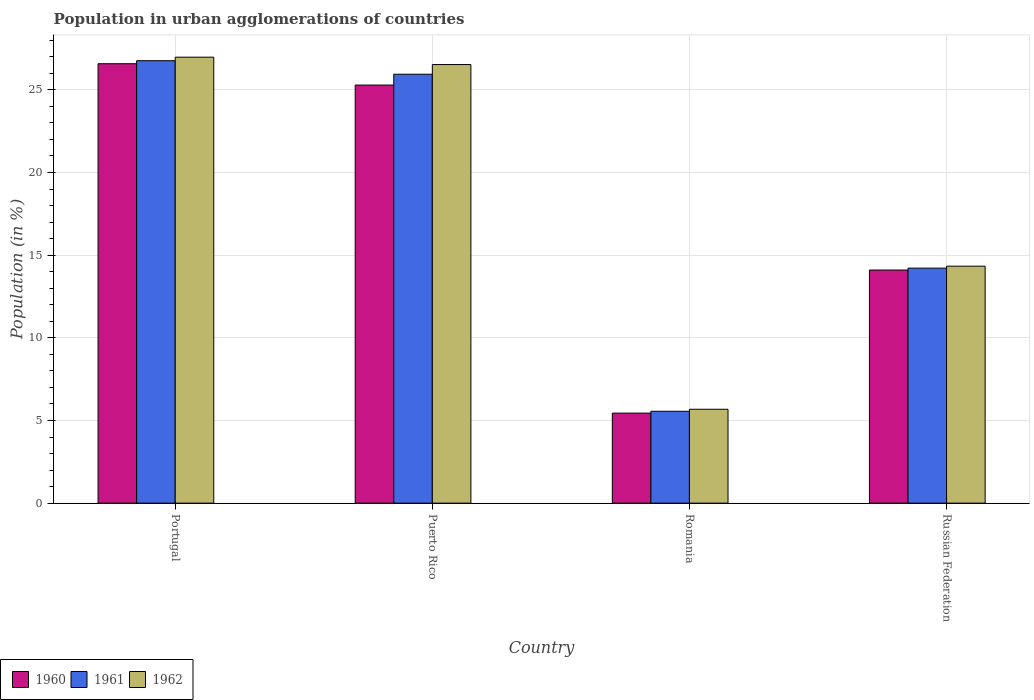How many different coloured bars are there?
Offer a terse response. 3. How many groups of bars are there?
Your response must be concise. 4. Are the number of bars per tick equal to the number of legend labels?
Keep it short and to the point. Yes. How many bars are there on the 3rd tick from the right?
Offer a terse response. 3. What is the label of the 4th group of bars from the left?
Make the answer very short. Russian Federation. What is the percentage of population in urban agglomerations in 1961 in Russian Federation?
Your answer should be very brief. 14.21. Across all countries, what is the maximum percentage of population in urban agglomerations in 1960?
Provide a succinct answer. 26.58. Across all countries, what is the minimum percentage of population in urban agglomerations in 1962?
Your response must be concise. 5.68. In which country was the percentage of population in urban agglomerations in 1962 minimum?
Make the answer very short. Romania. What is the total percentage of population in urban agglomerations in 1961 in the graph?
Ensure brevity in your answer.  72.47. What is the difference between the percentage of population in urban agglomerations in 1962 in Portugal and that in Puerto Rico?
Keep it short and to the point. 0.45. What is the difference between the percentage of population in urban agglomerations in 1962 in Portugal and the percentage of population in urban agglomerations in 1961 in Puerto Rico?
Make the answer very short. 1.03. What is the average percentage of population in urban agglomerations in 1962 per country?
Keep it short and to the point. 18.38. What is the difference between the percentage of population in urban agglomerations of/in 1961 and percentage of population in urban agglomerations of/in 1960 in Portugal?
Offer a very short reply. 0.18. What is the ratio of the percentage of population in urban agglomerations in 1962 in Portugal to that in Romania?
Make the answer very short. 4.75. What is the difference between the highest and the second highest percentage of population in urban agglomerations in 1961?
Keep it short and to the point. -0.82. What is the difference between the highest and the lowest percentage of population in urban agglomerations in 1960?
Offer a very short reply. 21.13. In how many countries, is the percentage of population in urban agglomerations in 1961 greater than the average percentage of population in urban agglomerations in 1961 taken over all countries?
Provide a short and direct response. 2. Is the sum of the percentage of population in urban agglomerations in 1962 in Puerto Rico and Romania greater than the maximum percentage of population in urban agglomerations in 1960 across all countries?
Ensure brevity in your answer.  Yes. What does the 1st bar from the right in Russian Federation represents?
Offer a very short reply. 1962. Is it the case that in every country, the sum of the percentage of population in urban agglomerations in 1960 and percentage of population in urban agglomerations in 1961 is greater than the percentage of population in urban agglomerations in 1962?
Your answer should be very brief. Yes. How many bars are there?
Your answer should be compact. 12. Are all the bars in the graph horizontal?
Your answer should be compact. No. What is the difference between two consecutive major ticks on the Y-axis?
Your answer should be compact. 5. Are the values on the major ticks of Y-axis written in scientific E-notation?
Make the answer very short. No. Does the graph contain any zero values?
Keep it short and to the point. No. Does the graph contain grids?
Your answer should be compact. Yes. What is the title of the graph?
Keep it short and to the point. Population in urban agglomerations of countries. What is the label or title of the X-axis?
Offer a terse response. Country. What is the Population (in %) in 1960 in Portugal?
Provide a succinct answer. 26.58. What is the Population (in %) in 1961 in Portugal?
Your response must be concise. 26.76. What is the Population (in %) in 1962 in Portugal?
Make the answer very short. 26.97. What is the Population (in %) of 1960 in Puerto Rico?
Keep it short and to the point. 25.29. What is the Population (in %) of 1961 in Puerto Rico?
Provide a short and direct response. 25.94. What is the Population (in %) of 1962 in Puerto Rico?
Offer a terse response. 26.53. What is the Population (in %) of 1960 in Romania?
Your answer should be compact. 5.45. What is the Population (in %) of 1961 in Romania?
Make the answer very short. 5.56. What is the Population (in %) in 1962 in Romania?
Make the answer very short. 5.68. What is the Population (in %) in 1960 in Russian Federation?
Offer a very short reply. 14.1. What is the Population (in %) in 1961 in Russian Federation?
Your response must be concise. 14.21. What is the Population (in %) of 1962 in Russian Federation?
Give a very brief answer. 14.33. Across all countries, what is the maximum Population (in %) in 1960?
Your answer should be compact. 26.58. Across all countries, what is the maximum Population (in %) of 1961?
Ensure brevity in your answer.  26.76. Across all countries, what is the maximum Population (in %) of 1962?
Offer a terse response. 26.97. Across all countries, what is the minimum Population (in %) in 1960?
Provide a short and direct response. 5.45. Across all countries, what is the minimum Population (in %) of 1961?
Keep it short and to the point. 5.56. Across all countries, what is the minimum Population (in %) of 1962?
Give a very brief answer. 5.68. What is the total Population (in %) in 1960 in the graph?
Your answer should be very brief. 71.41. What is the total Population (in %) of 1961 in the graph?
Provide a short and direct response. 72.47. What is the total Population (in %) of 1962 in the graph?
Provide a short and direct response. 73.51. What is the difference between the Population (in %) of 1960 in Portugal and that in Puerto Rico?
Ensure brevity in your answer.  1.29. What is the difference between the Population (in %) of 1961 in Portugal and that in Puerto Rico?
Keep it short and to the point. 0.82. What is the difference between the Population (in %) of 1962 in Portugal and that in Puerto Rico?
Ensure brevity in your answer.  0.45. What is the difference between the Population (in %) in 1960 in Portugal and that in Romania?
Provide a short and direct response. 21.13. What is the difference between the Population (in %) of 1961 in Portugal and that in Romania?
Your answer should be compact. 21.2. What is the difference between the Population (in %) of 1962 in Portugal and that in Romania?
Offer a terse response. 21.3. What is the difference between the Population (in %) in 1960 in Portugal and that in Russian Federation?
Offer a very short reply. 12.48. What is the difference between the Population (in %) of 1961 in Portugal and that in Russian Federation?
Offer a very short reply. 12.54. What is the difference between the Population (in %) in 1962 in Portugal and that in Russian Federation?
Offer a terse response. 12.64. What is the difference between the Population (in %) of 1960 in Puerto Rico and that in Romania?
Provide a succinct answer. 19.84. What is the difference between the Population (in %) in 1961 in Puerto Rico and that in Romania?
Give a very brief answer. 20.39. What is the difference between the Population (in %) of 1962 in Puerto Rico and that in Romania?
Your answer should be compact. 20.85. What is the difference between the Population (in %) of 1960 in Puerto Rico and that in Russian Federation?
Your response must be concise. 11.19. What is the difference between the Population (in %) in 1961 in Puerto Rico and that in Russian Federation?
Ensure brevity in your answer.  11.73. What is the difference between the Population (in %) in 1962 in Puerto Rico and that in Russian Federation?
Ensure brevity in your answer.  12.19. What is the difference between the Population (in %) in 1960 in Romania and that in Russian Federation?
Your response must be concise. -8.65. What is the difference between the Population (in %) in 1961 in Romania and that in Russian Federation?
Provide a short and direct response. -8.66. What is the difference between the Population (in %) in 1962 in Romania and that in Russian Federation?
Provide a short and direct response. -8.65. What is the difference between the Population (in %) in 1960 in Portugal and the Population (in %) in 1961 in Puerto Rico?
Your answer should be very brief. 0.64. What is the difference between the Population (in %) of 1960 in Portugal and the Population (in %) of 1962 in Puerto Rico?
Give a very brief answer. 0.05. What is the difference between the Population (in %) in 1961 in Portugal and the Population (in %) in 1962 in Puerto Rico?
Your answer should be compact. 0.23. What is the difference between the Population (in %) in 1960 in Portugal and the Population (in %) in 1961 in Romania?
Your response must be concise. 21.02. What is the difference between the Population (in %) in 1960 in Portugal and the Population (in %) in 1962 in Romania?
Make the answer very short. 20.9. What is the difference between the Population (in %) in 1961 in Portugal and the Population (in %) in 1962 in Romania?
Offer a very short reply. 21.08. What is the difference between the Population (in %) of 1960 in Portugal and the Population (in %) of 1961 in Russian Federation?
Give a very brief answer. 12.36. What is the difference between the Population (in %) of 1960 in Portugal and the Population (in %) of 1962 in Russian Federation?
Your answer should be very brief. 12.24. What is the difference between the Population (in %) in 1961 in Portugal and the Population (in %) in 1962 in Russian Federation?
Keep it short and to the point. 12.43. What is the difference between the Population (in %) of 1960 in Puerto Rico and the Population (in %) of 1961 in Romania?
Provide a short and direct response. 19.73. What is the difference between the Population (in %) in 1960 in Puerto Rico and the Population (in %) in 1962 in Romania?
Provide a short and direct response. 19.61. What is the difference between the Population (in %) in 1961 in Puerto Rico and the Population (in %) in 1962 in Romania?
Give a very brief answer. 20.26. What is the difference between the Population (in %) of 1960 in Puerto Rico and the Population (in %) of 1961 in Russian Federation?
Your response must be concise. 11.07. What is the difference between the Population (in %) of 1960 in Puerto Rico and the Population (in %) of 1962 in Russian Federation?
Keep it short and to the point. 10.95. What is the difference between the Population (in %) in 1961 in Puerto Rico and the Population (in %) in 1962 in Russian Federation?
Provide a succinct answer. 11.61. What is the difference between the Population (in %) of 1960 in Romania and the Population (in %) of 1961 in Russian Federation?
Ensure brevity in your answer.  -8.77. What is the difference between the Population (in %) in 1960 in Romania and the Population (in %) in 1962 in Russian Federation?
Your response must be concise. -8.89. What is the difference between the Population (in %) in 1961 in Romania and the Population (in %) in 1962 in Russian Federation?
Provide a succinct answer. -8.78. What is the average Population (in %) of 1960 per country?
Make the answer very short. 17.85. What is the average Population (in %) of 1961 per country?
Give a very brief answer. 18.12. What is the average Population (in %) of 1962 per country?
Make the answer very short. 18.38. What is the difference between the Population (in %) of 1960 and Population (in %) of 1961 in Portugal?
Offer a terse response. -0.18. What is the difference between the Population (in %) of 1960 and Population (in %) of 1962 in Portugal?
Provide a short and direct response. -0.4. What is the difference between the Population (in %) of 1961 and Population (in %) of 1962 in Portugal?
Offer a terse response. -0.21. What is the difference between the Population (in %) in 1960 and Population (in %) in 1961 in Puerto Rico?
Ensure brevity in your answer.  -0.65. What is the difference between the Population (in %) of 1960 and Population (in %) of 1962 in Puerto Rico?
Your answer should be compact. -1.24. What is the difference between the Population (in %) in 1961 and Population (in %) in 1962 in Puerto Rico?
Keep it short and to the point. -0.58. What is the difference between the Population (in %) in 1960 and Population (in %) in 1961 in Romania?
Give a very brief answer. -0.11. What is the difference between the Population (in %) of 1960 and Population (in %) of 1962 in Romania?
Offer a terse response. -0.23. What is the difference between the Population (in %) of 1961 and Population (in %) of 1962 in Romania?
Keep it short and to the point. -0.12. What is the difference between the Population (in %) in 1960 and Population (in %) in 1961 in Russian Federation?
Offer a very short reply. -0.12. What is the difference between the Population (in %) in 1960 and Population (in %) in 1962 in Russian Federation?
Your answer should be compact. -0.23. What is the difference between the Population (in %) of 1961 and Population (in %) of 1962 in Russian Federation?
Your response must be concise. -0.12. What is the ratio of the Population (in %) of 1960 in Portugal to that in Puerto Rico?
Ensure brevity in your answer.  1.05. What is the ratio of the Population (in %) of 1961 in Portugal to that in Puerto Rico?
Your answer should be compact. 1.03. What is the ratio of the Population (in %) in 1962 in Portugal to that in Puerto Rico?
Ensure brevity in your answer.  1.02. What is the ratio of the Population (in %) in 1960 in Portugal to that in Romania?
Keep it short and to the point. 4.88. What is the ratio of the Population (in %) of 1961 in Portugal to that in Romania?
Keep it short and to the point. 4.82. What is the ratio of the Population (in %) in 1962 in Portugal to that in Romania?
Offer a very short reply. 4.75. What is the ratio of the Population (in %) in 1960 in Portugal to that in Russian Federation?
Give a very brief answer. 1.89. What is the ratio of the Population (in %) in 1961 in Portugal to that in Russian Federation?
Ensure brevity in your answer.  1.88. What is the ratio of the Population (in %) in 1962 in Portugal to that in Russian Federation?
Provide a succinct answer. 1.88. What is the ratio of the Population (in %) of 1960 in Puerto Rico to that in Romania?
Make the answer very short. 4.64. What is the ratio of the Population (in %) of 1961 in Puerto Rico to that in Romania?
Give a very brief answer. 4.67. What is the ratio of the Population (in %) in 1962 in Puerto Rico to that in Romania?
Keep it short and to the point. 4.67. What is the ratio of the Population (in %) in 1960 in Puerto Rico to that in Russian Federation?
Your answer should be compact. 1.79. What is the ratio of the Population (in %) of 1961 in Puerto Rico to that in Russian Federation?
Keep it short and to the point. 1.82. What is the ratio of the Population (in %) in 1962 in Puerto Rico to that in Russian Federation?
Your response must be concise. 1.85. What is the ratio of the Population (in %) in 1960 in Romania to that in Russian Federation?
Your response must be concise. 0.39. What is the ratio of the Population (in %) in 1961 in Romania to that in Russian Federation?
Offer a very short reply. 0.39. What is the ratio of the Population (in %) in 1962 in Romania to that in Russian Federation?
Keep it short and to the point. 0.4. What is the difference between the highest and the second highest Population (in %) in 1960?
Give a very brief answer. 1.29. What is the difference between the highest and the second highest Population (in %) in 1961?
Provide a succinct answer. 0.82. What is the difference between the highest and the second highest Population (in %) of 1962?
Keep it short and to the point. 0.45. What is the difference between the highest and the lowest Population (in %) of 1960?
Your answer should be very brief. 21.13. What is the difference between the highest and the lowest Population (in %) of 1961?
Your response must be concise. 21.2. What is the difference between the highest and the lowest Population (in %) of 1962?
Ensure brevity in your answer.  21.3. 